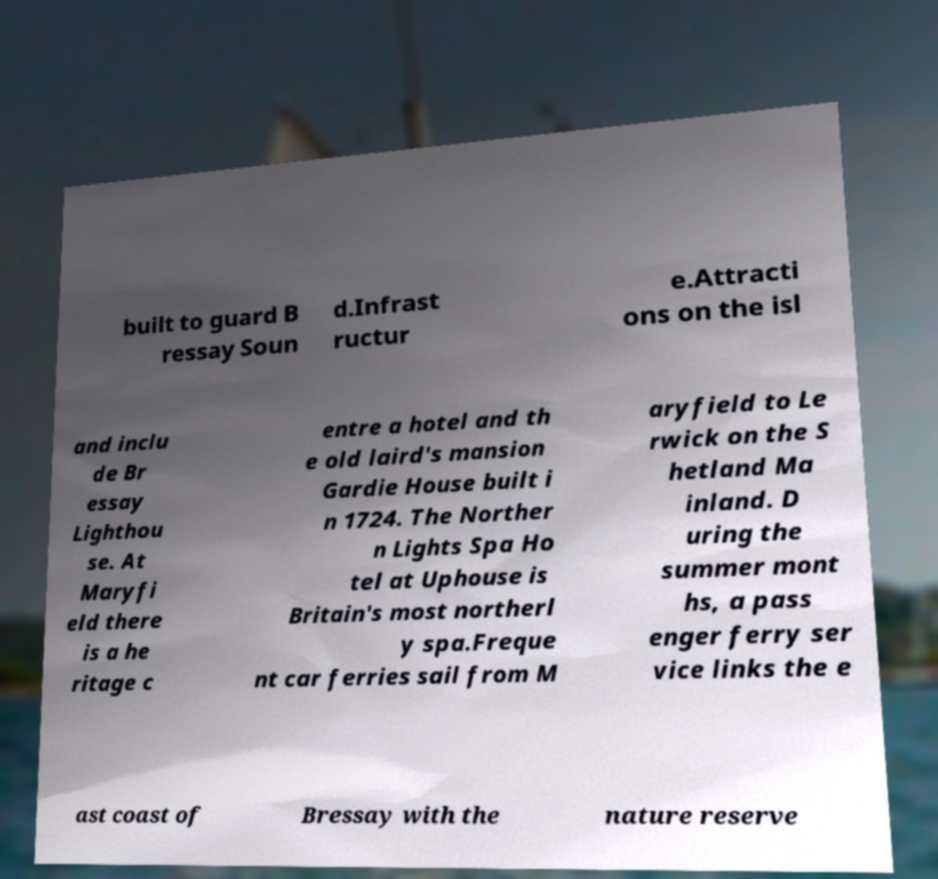There's text embedded in this image that I need extracted. Can you transcribe it verbatim? built to guard B ressay Soun d.Infrast ructur e.Attracti ons on the isl and inclu de Br essay Lighthou se. At Maryfi eld there is a he ritage c entre a hotel and th e old laird's mansion Gardie House built i n 1724. The Norther n Lights Spa Ho tel at Uphouse is Britain's most northerl y spa.Freque nt car ferries sail from M aryfield to Le rwick on the S hetland Ma inland. D uring the summer mont hs, a pass enger ferry ser vice links the e ast coast of Bressay with the nature reserve 